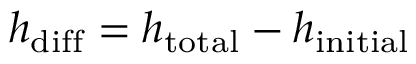<formula> <loc_0><loc_0><loc_500><loc_500>h _ { d i f f } = h _ { t o t a l } - h _ { i n i t i a l }</formula> 